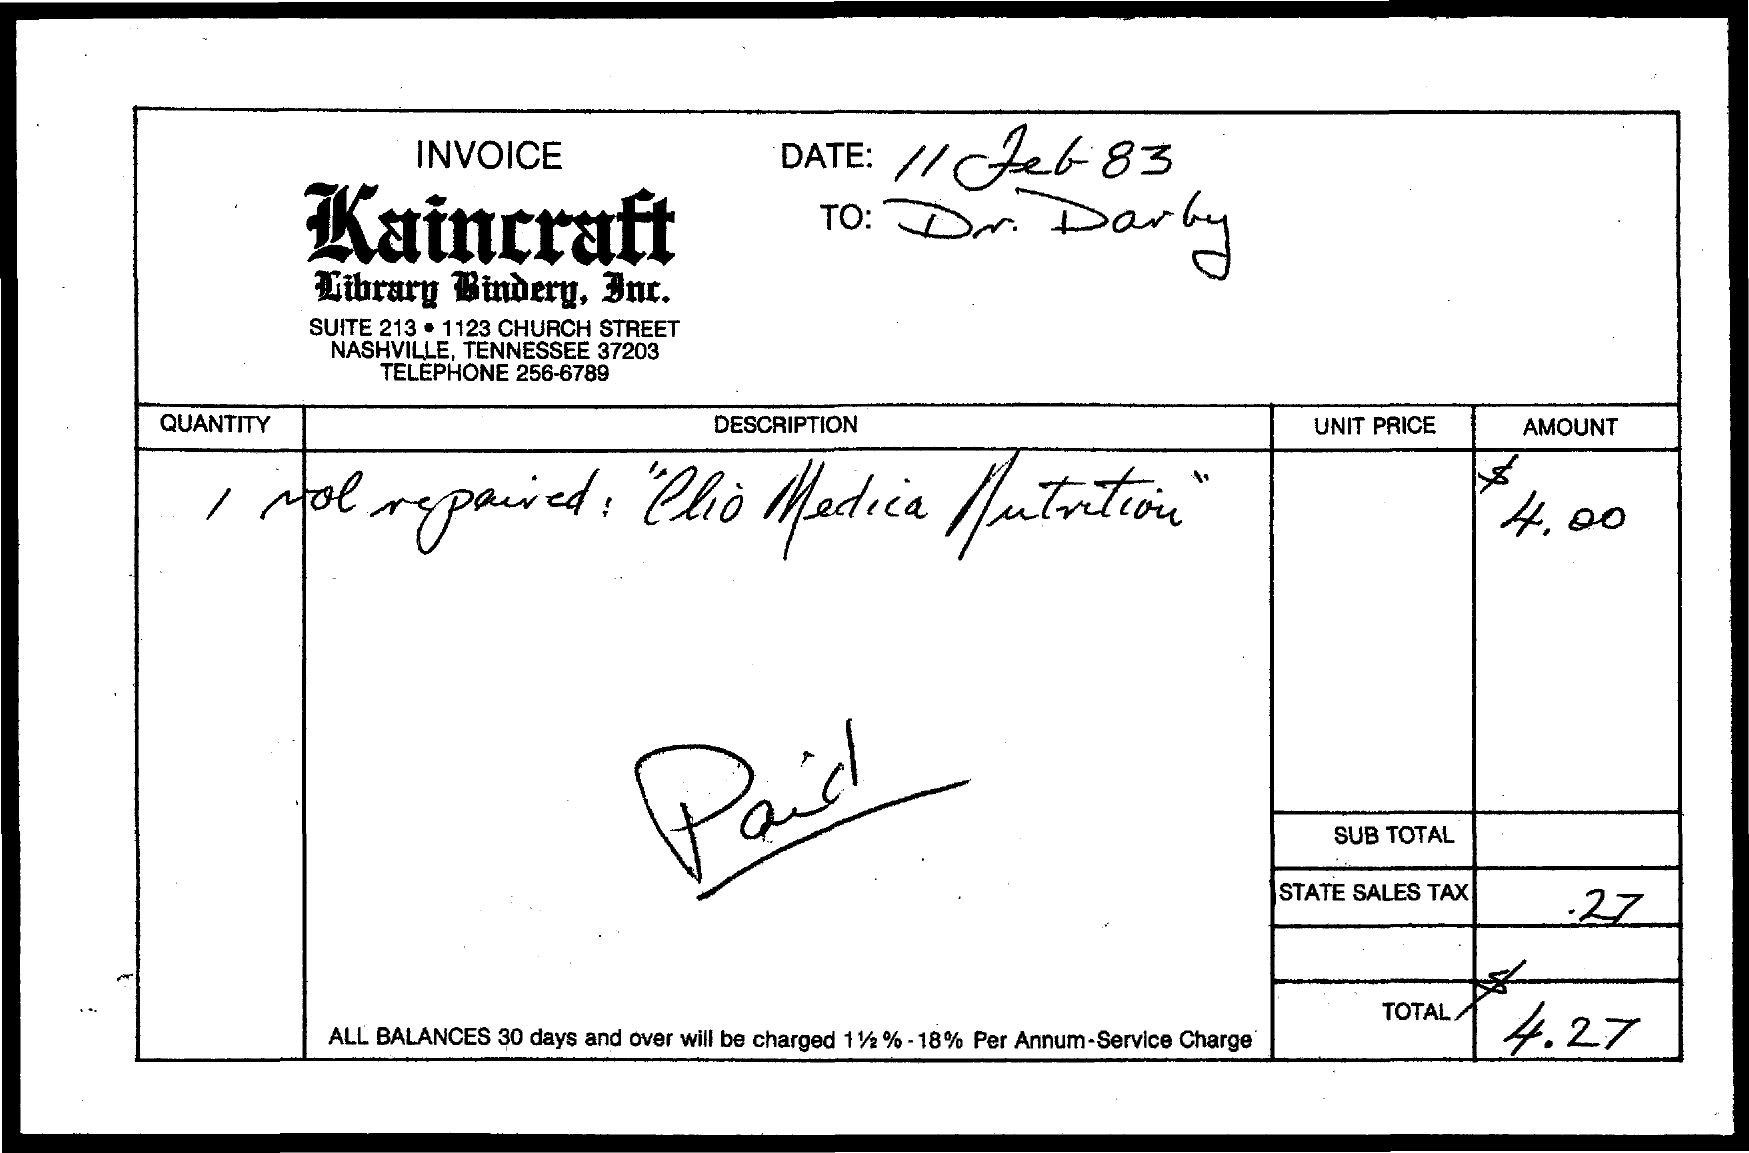Point out several critical features in this image. The state sales tax is 0.27%. The total amount is $4.27. The document indicates that the date is February 11th, 1983. 